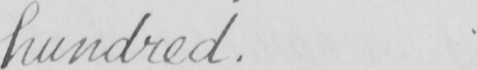Transcribe the text shown in this historical manuscript line. hundred . 